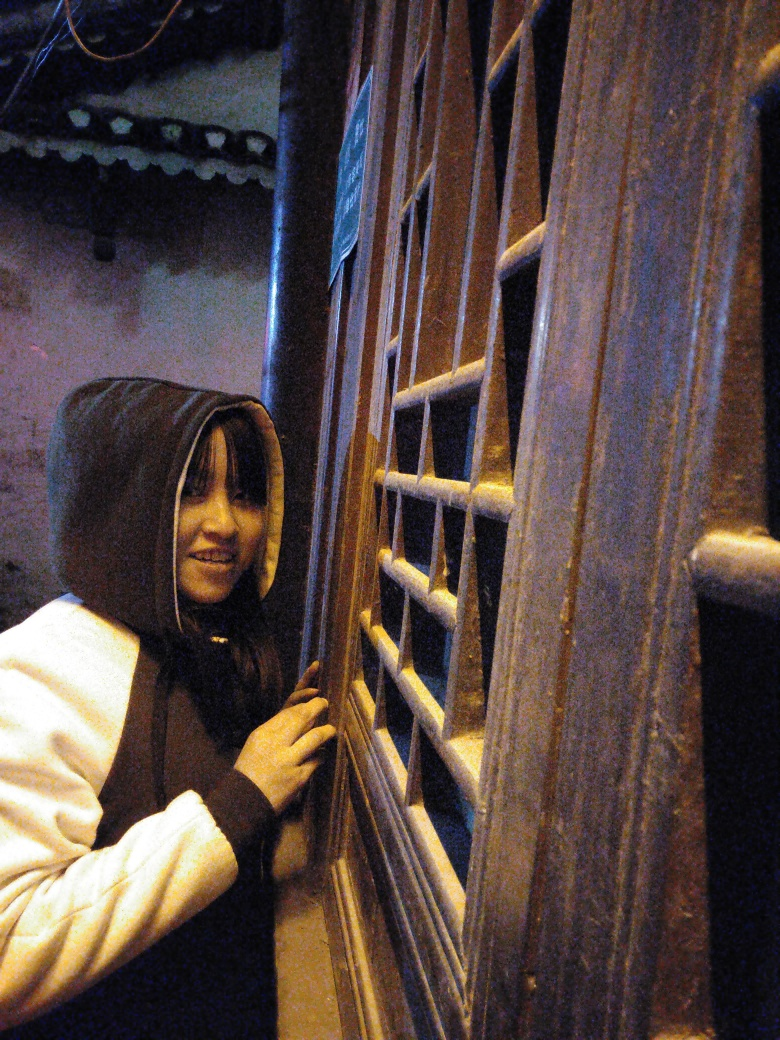Can you infer what time of day it might be in this image? Given the dim lighting and the use of artificial light sources, it seems to be either dusk or night time, suggestive of after-hours or a time typical for privacy and seclusion. 